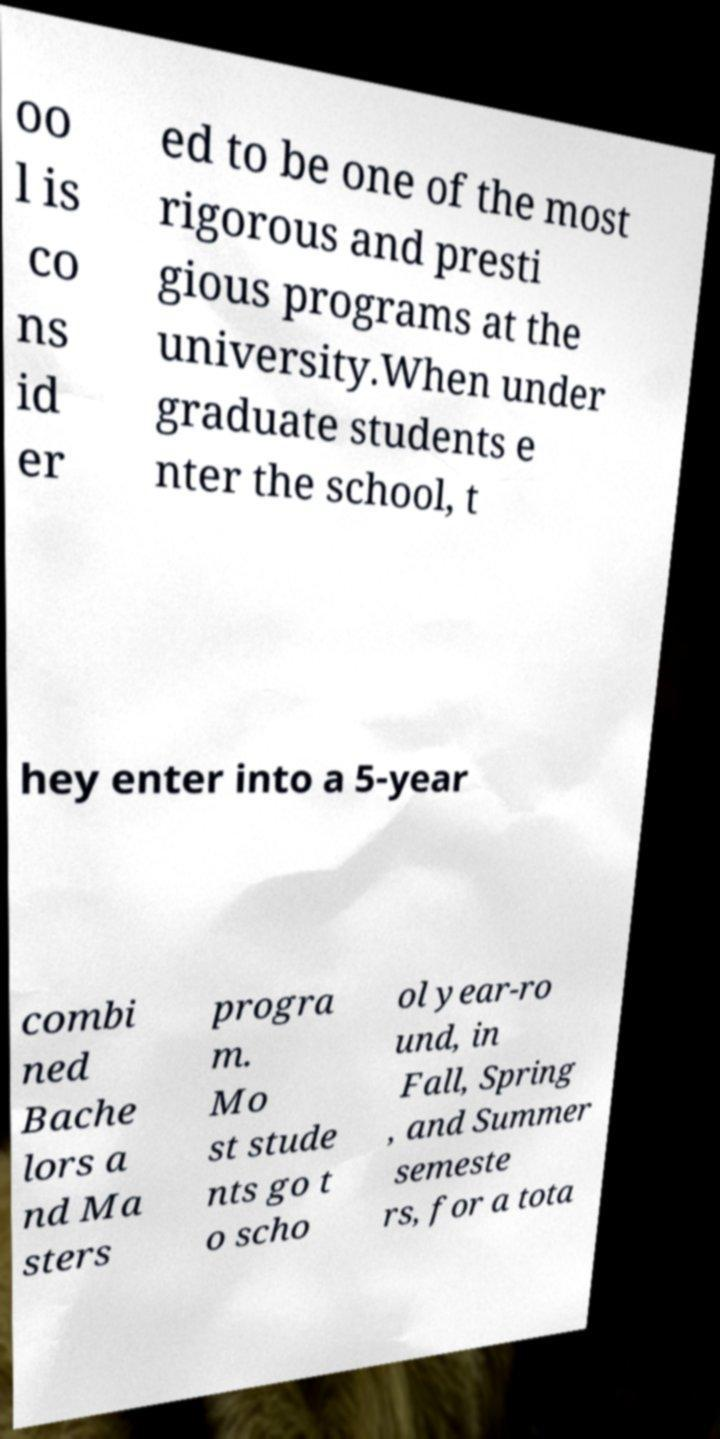What messages or text are displayed in this image? I need them in a readable, typed format. oo l is co ns id er ed to be one of the most rigorous and presti gious programs at the university.When under graduate students e nter the school, t hey enter into a 5-year combi ned Bache lors a nd Ma sters progra m. Mo st stude nts go t o scho ol year-ro und, in Fall, Spring , and Summer semeste rs, for a tota 